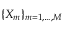Convert formula to latex. <formula><loc_0><loc_0><loc_500><loc_500>\{ X _ { m } \} _ { m = 1 , \dots , M }</formula> 